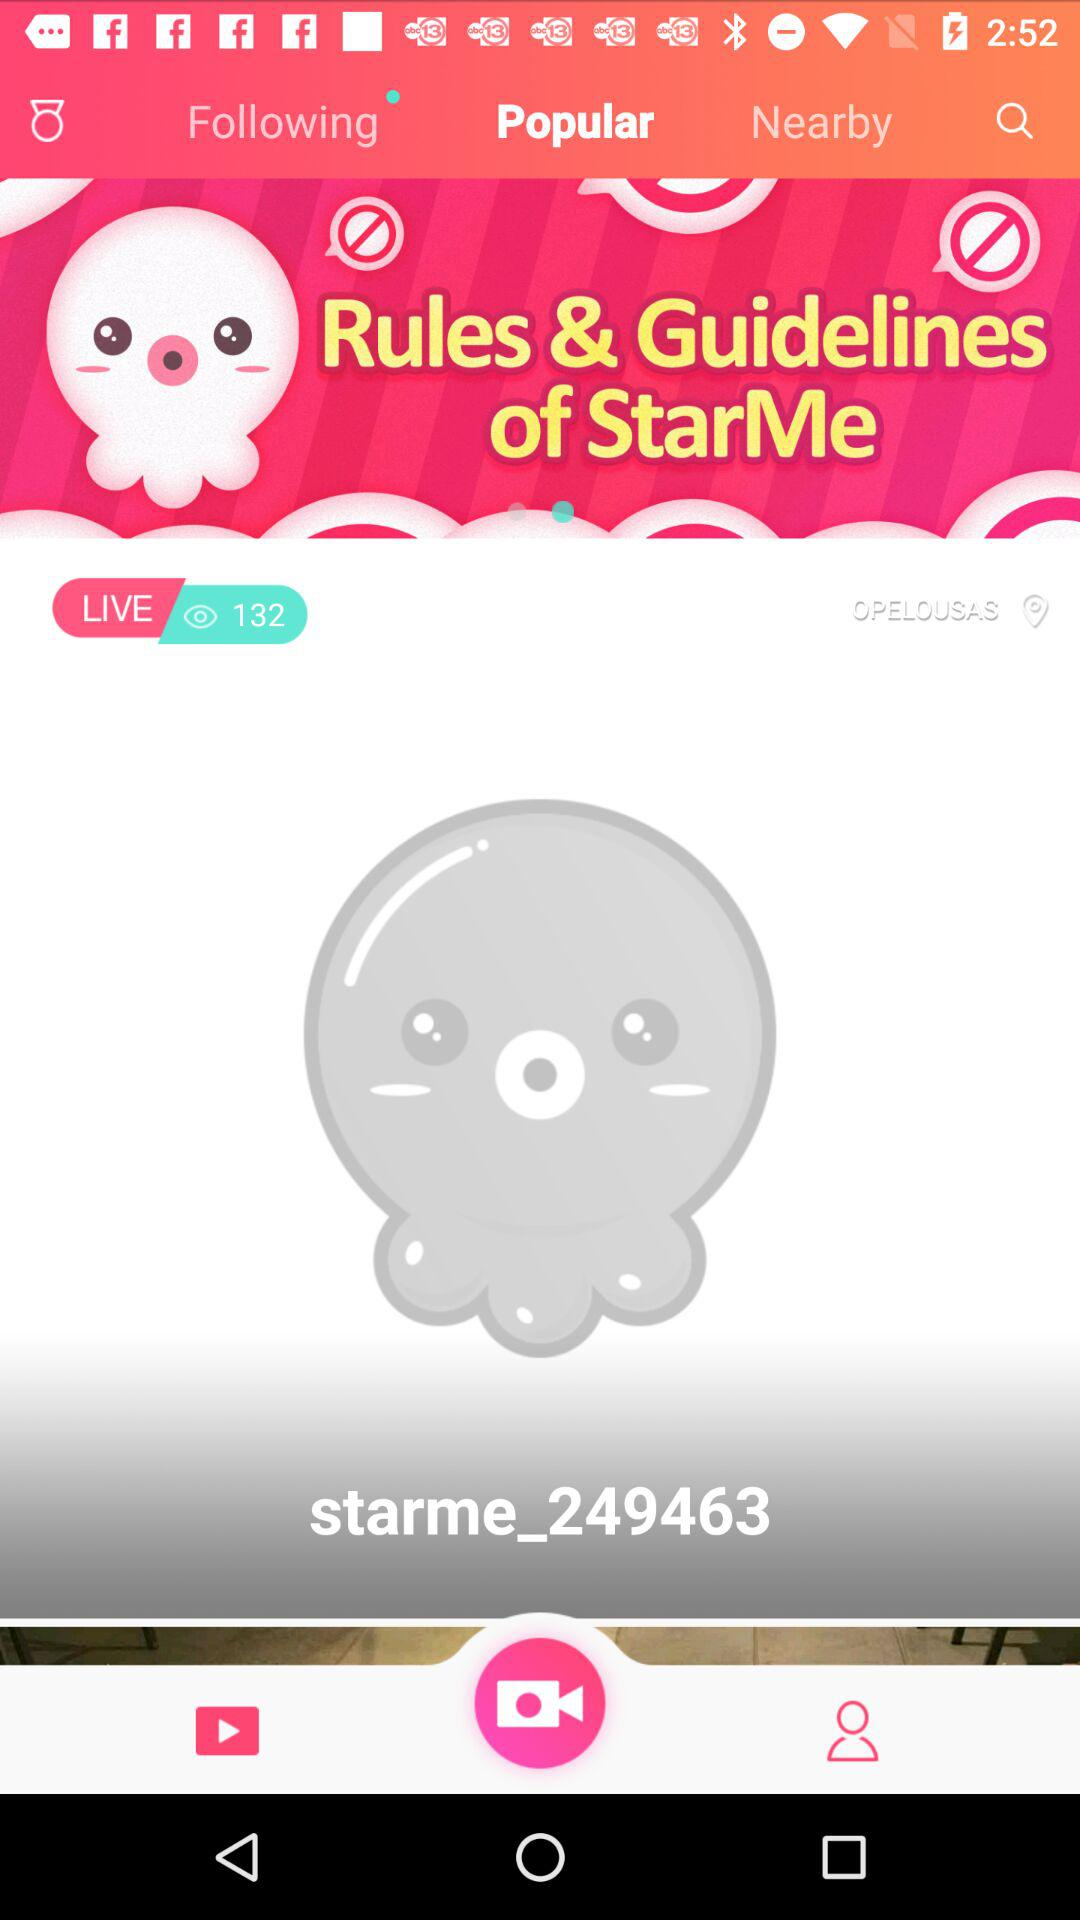How many people are watching this video? There are 132 people who are watching this video. 